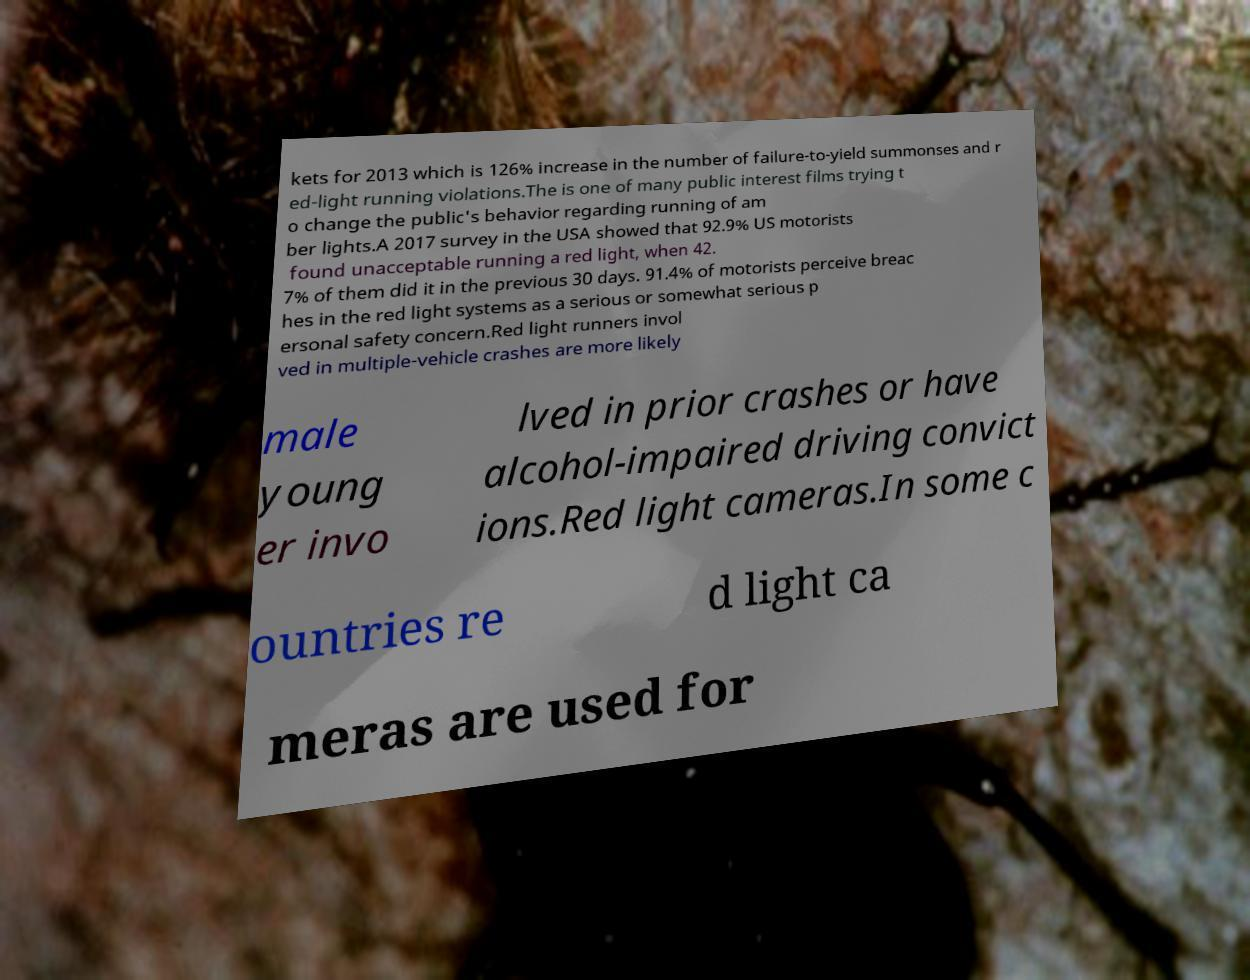Please read and relay the text visible in this image. What does it say? kets for 2013 which is 126% increase in the number of failure-to-yield summonses and r ed-light running violations.The is one of many public interest films trying t o change the public's behavior regarding running of am ber lights.A 2017 survey in the USA showed that 92.9% US motorists found unacceptable running a red light, when 42. 7% of them did it in the previous 30 days. 91.4% of motorists perceive breac hes in the red light systems as a serious or somewhat serious p ersonal safety concern.Red light runners invol ved in multiple-vehicle crashes are more likely male young er invo lved in prior crashes or have alcohol-impaired driving convict ions.Red light cameras.In some c ountries re d light ca meras are used for 